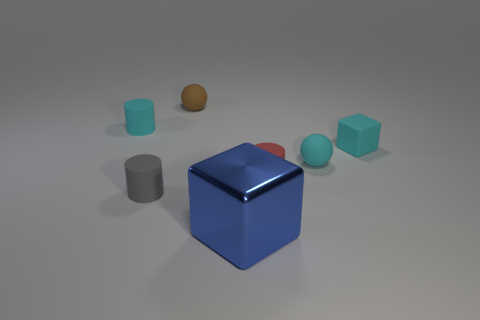There is a rubber sphere that is right of the blue metallic block; is there a cyan cylinder to the right of it?
Provide a succinct answer. No. There is a cylinder that is left of the tiny gray matte cylinder; how many big blue things are behind it?
Your answer should be compact. 0. There is a brown thing that is the same size as the red matte cylinder; what is its material?
Ensure brevity in your answer.  Rubber. Do the small cyan matte thing that is in front of the small cyan cube and the metal object have the same shape?
Keep it short and to the point. No. Is the number of blue cubes to the right of the small gray rubber cylinder greater than the number of brown rubber objects that are in front of the small block?
Offer a terse response. Yes. How many tiny cyan things have the same material as the tiny red cylinder?
Provide a succinct answer. 3. Is the metal block the same size as the cyan block?
Give a very brief answer. No. The big cube is what color?
Keep it short and to the point. Blue. How many objects are red things or cyan things?
Offer a very short reply. 4. Is there another red object of the same shape as the big shiny object?
Your answer should be very brief. No. 